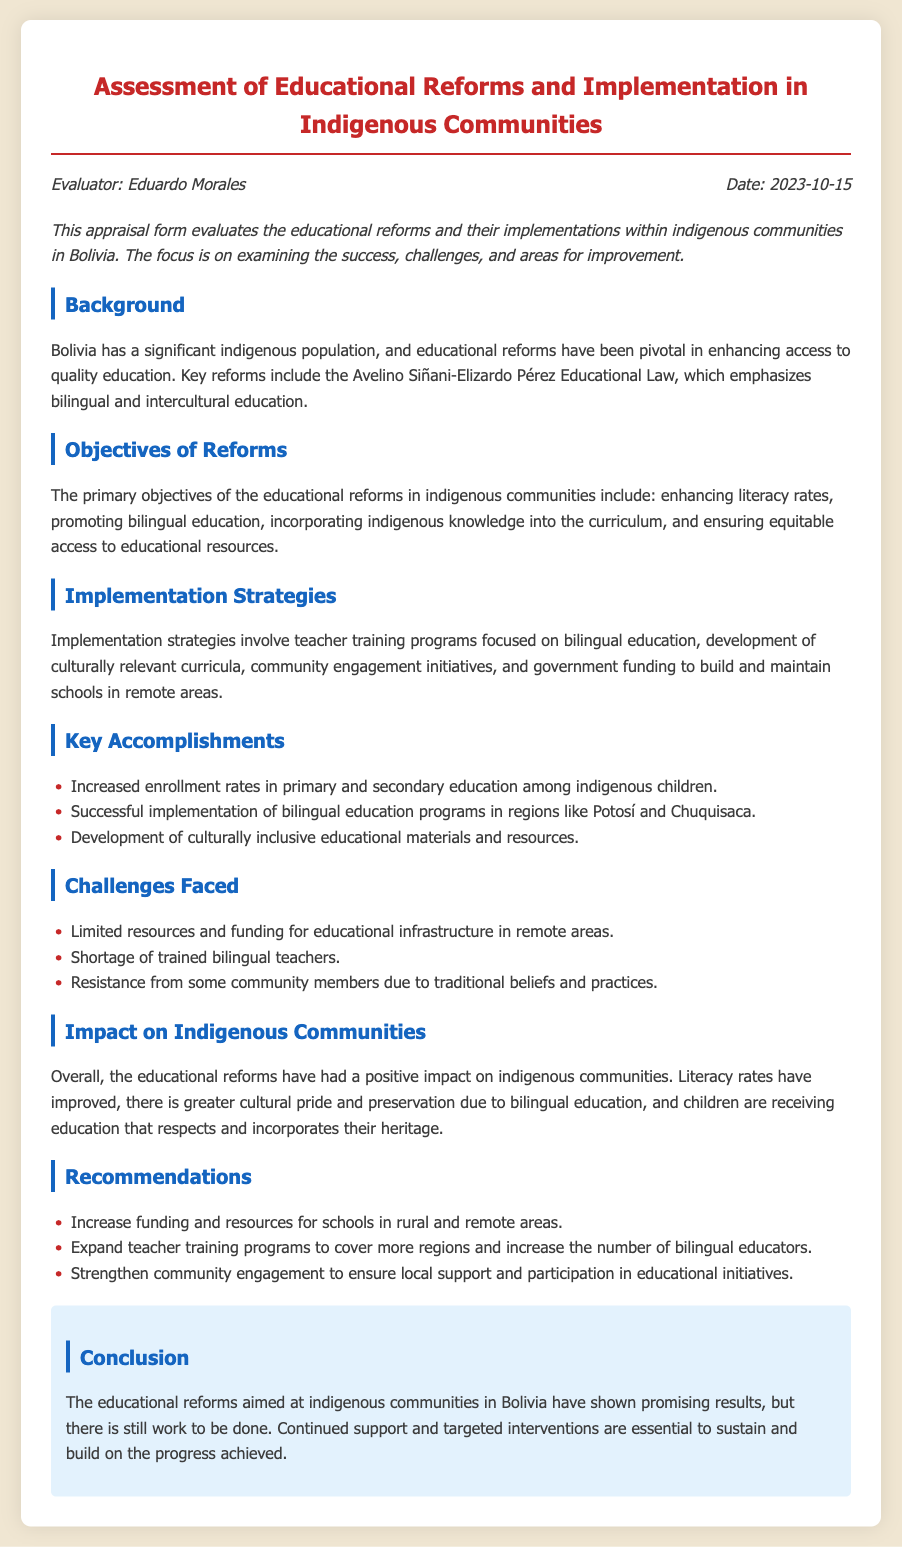What are the key reforms mentioned in the document? The key reforms include the Avelino Siñani-Elizardo Pérez Educational Law, which emphasizes bilingual and intercultural education.
Answer: Avelino Siñani-Elizardo Pérez Educational Law Who is the evaluator of this appraisal form? The evaluator's name is listed in the meta section of the document.
Answer: Eduardo Morales What is the date of the appraisal? The date is specified in the meta section as the date of evaluation.
Answer: 2023-10-15 What is one of the challenges faced in the implementation of the reforms? The challenges section outlines specific issues encountered during implementation.
Answer: Limited resources and funding What is a key accomplishment achieved by the reforms? The accomplishments list noteworthy outcomes of the educational reforms.
Answer: Increased enrollment rates What is one of the recommendations made in the document? Recommendations provide suggestions for improving the educational system.
Answer: Increase funding and resources What is the primary objective of the educational reforms? The primary objective is stated clearly in the objectives section of the document.
Answer: Enhancing literacy rates What impact has the educational reforms had on indigenous communities? The impact summarizes the general effects of the reforms on the communities.
Answer: Positive impact How many implementation strategies are listed in the document? The implementation strategies section contains a specific number of strategies outlined.
Answer: Four 